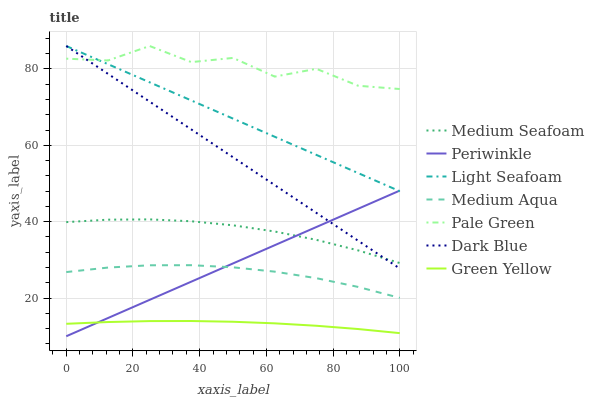Does Green Yellow have the minimum area under the curve?
Answer yes or no. Yes. Does Pale Green have the maximum area under the curve?
Answer yes or no. Yes. Does Dark Blue have the minimum area under the curve?
Answer yes or no. No. Does Dark Blue have the maximum area under the curve?
Answer yes or no. No. Is Periwinkle the smoothest?
Answer yes or no. Yes. Is Pale Green the roughest?
Answer yes or no. Yes. Is Dark Blue the smoothest?
Answer yes or no. No. Is Dark Blue the roughest?
Answer yes or no. No. Does Periwinkle have the lowest value?
Answer yes or no. Yes. Does Dark Blue have the lowest value?
Answer yes or no. No. Does Light Seafoam have the highest value?
Answer yes or no. Yes. Does Medium Aqua have the highest value?
Answer yes or no. No. Is Medium Aqua less than Dark Blue?
Answer yes or no. Yes. Is Light Seafoam greater than Green Yellow?
Answer yes or no. Yes. Does Light Seafoam intersect Pale Green?
Answer yes or no. Yes. Is Light Seafoam less than Pale Green?
Answer yes or no. No. Is Light Seafoam greater than Pale Green?
Answer yes or no. No. Does Medium Aqua intersect Dark Blue?
Answer yes or no. No. 